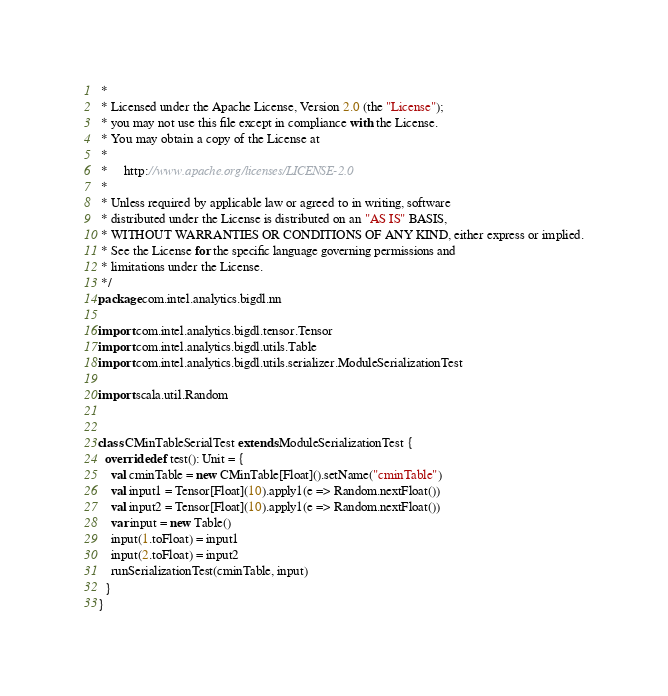Convert code to text. <code><loc_0><loc_0><loc_500><loc_500><_Scala_> *
 * Licensed under the Apache License, Version 2.0 (the "License");
 * you may not use this file except in compliance with the License.
 * You may obtain a copy of the License at
 *
 *     http://www.apache.org/licenses/LICENSE-2.0
 *
 * Unless required by applicable law or agreed to in writing, software
 * distributed under the License is distributed on an "AS IS" BASIS,
 * WITHOUT WARRANTIES OR CONDITIONS OF ANY KIND, either express or implied.
 * See the License for the specific language governing permissions and
 * limitations under the License.
 */
package com.intel.analytics.bigdl.nn

import com.intel.analytics.bigdl.tensor.Tensor
import com.intel.analytics.bigdl.utils.Table
import com.intel.analytics.bigdl.utils.serializer.ModuleSerializationTest

import scala.util.Random


class CMinTableSerialTest extends ModuleSerializationTest {
  override def test(): Unit = {
    val cminTable = new CMinTable[Float]().setName("cminTable")
    val input1 = Tensor[Float](10).apply1(e => Random.nextFloat())
    val input2 = Tensor[Float](10).apply1(e => Random.nextFloat())
    var input = new Table()
    input(1.toFloat) = input1
    input(2.toFloat) = input2
    runSerializationTest(cminTable, input)
  }
}
</code> 